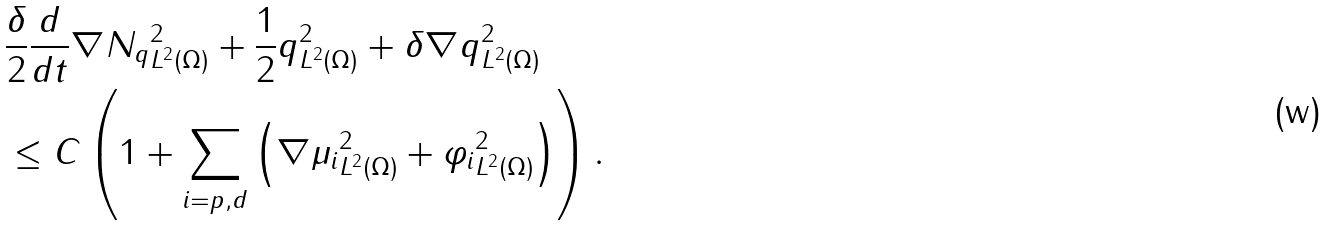Convert formula to latex. <formula><loc_0><loc_0><loc_500><loc_500>& \frac { \delta } { 2 } \frac { d } { d t } \| \nabla N _ { q } \| _ { L ^ { 2 } ( \Omega ) } ^ { 2 } + \frac { 1 } { 2 } \| q \| _ { L ^ { 2 } ( \Omega ) } ^ { 2 } + \delta \| \nabla q \| _ { L ^ { 2 } ( \Omega ) } ^ { 2 } \\ & \leq C \left ( 1 + \sum _ { i = p , d } \left ( \| \nabla \mu _ { i } \| _ { L ^ { 2 } ( \Omega ) } ^ { 2 } + \| \varphi _ { i } \| _ { L ^ { 2 } ( \Omega ) } ^ { 2 } \right ) \right ) .</formula> 